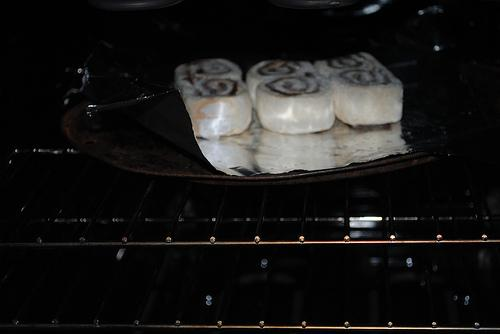What is an interesting observation about the surface where the rolls are placed? There is a reflection of the rolls on the sheet. Comment on the state of the cinnamon rolls. The cinnamon rolls are uncooked. Identify the type of rolls seen in the image. The rolls in the image are cinnamon rolls. What is the design of the cake in the image? There is a swirl design in the middle of the cake. What is the color of the oven, according to the given information? The oven is dark. What can be seen reflecting on the cinnamon rolls? Light from the foil is reflected on the cinnamon rolls. How many cinnamon rolls are there in the oven? There are six cinnamon rolls in the oven. Mention the color of the buns and any design within them. The buns are white with a brown cinnamon swirl inside them. Describe a notable feature of the oven rack. The oven rack is made of metal. What is covering the pan inside the oven? A piece of aluminum foil is covering the pan. 